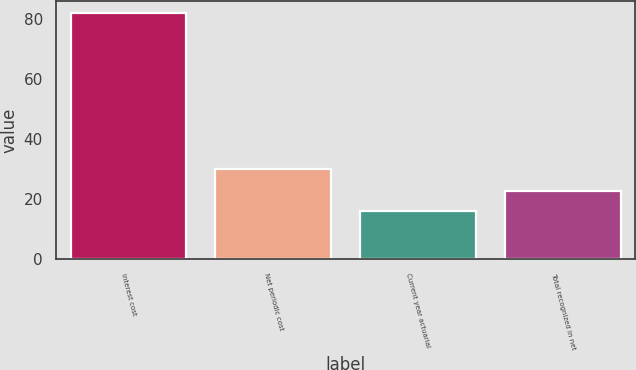Convert chart. <chart><loc_0><loc_0><loc_500><loc_500><bar_chart><fcel>Interest cost<fcel>Net periodic cost<fcel>Current year actuarial<fcel>Total recognized in net<nl><fcel>82<fcel>30<fcel>16<fcel>22.6<nl></chart> 